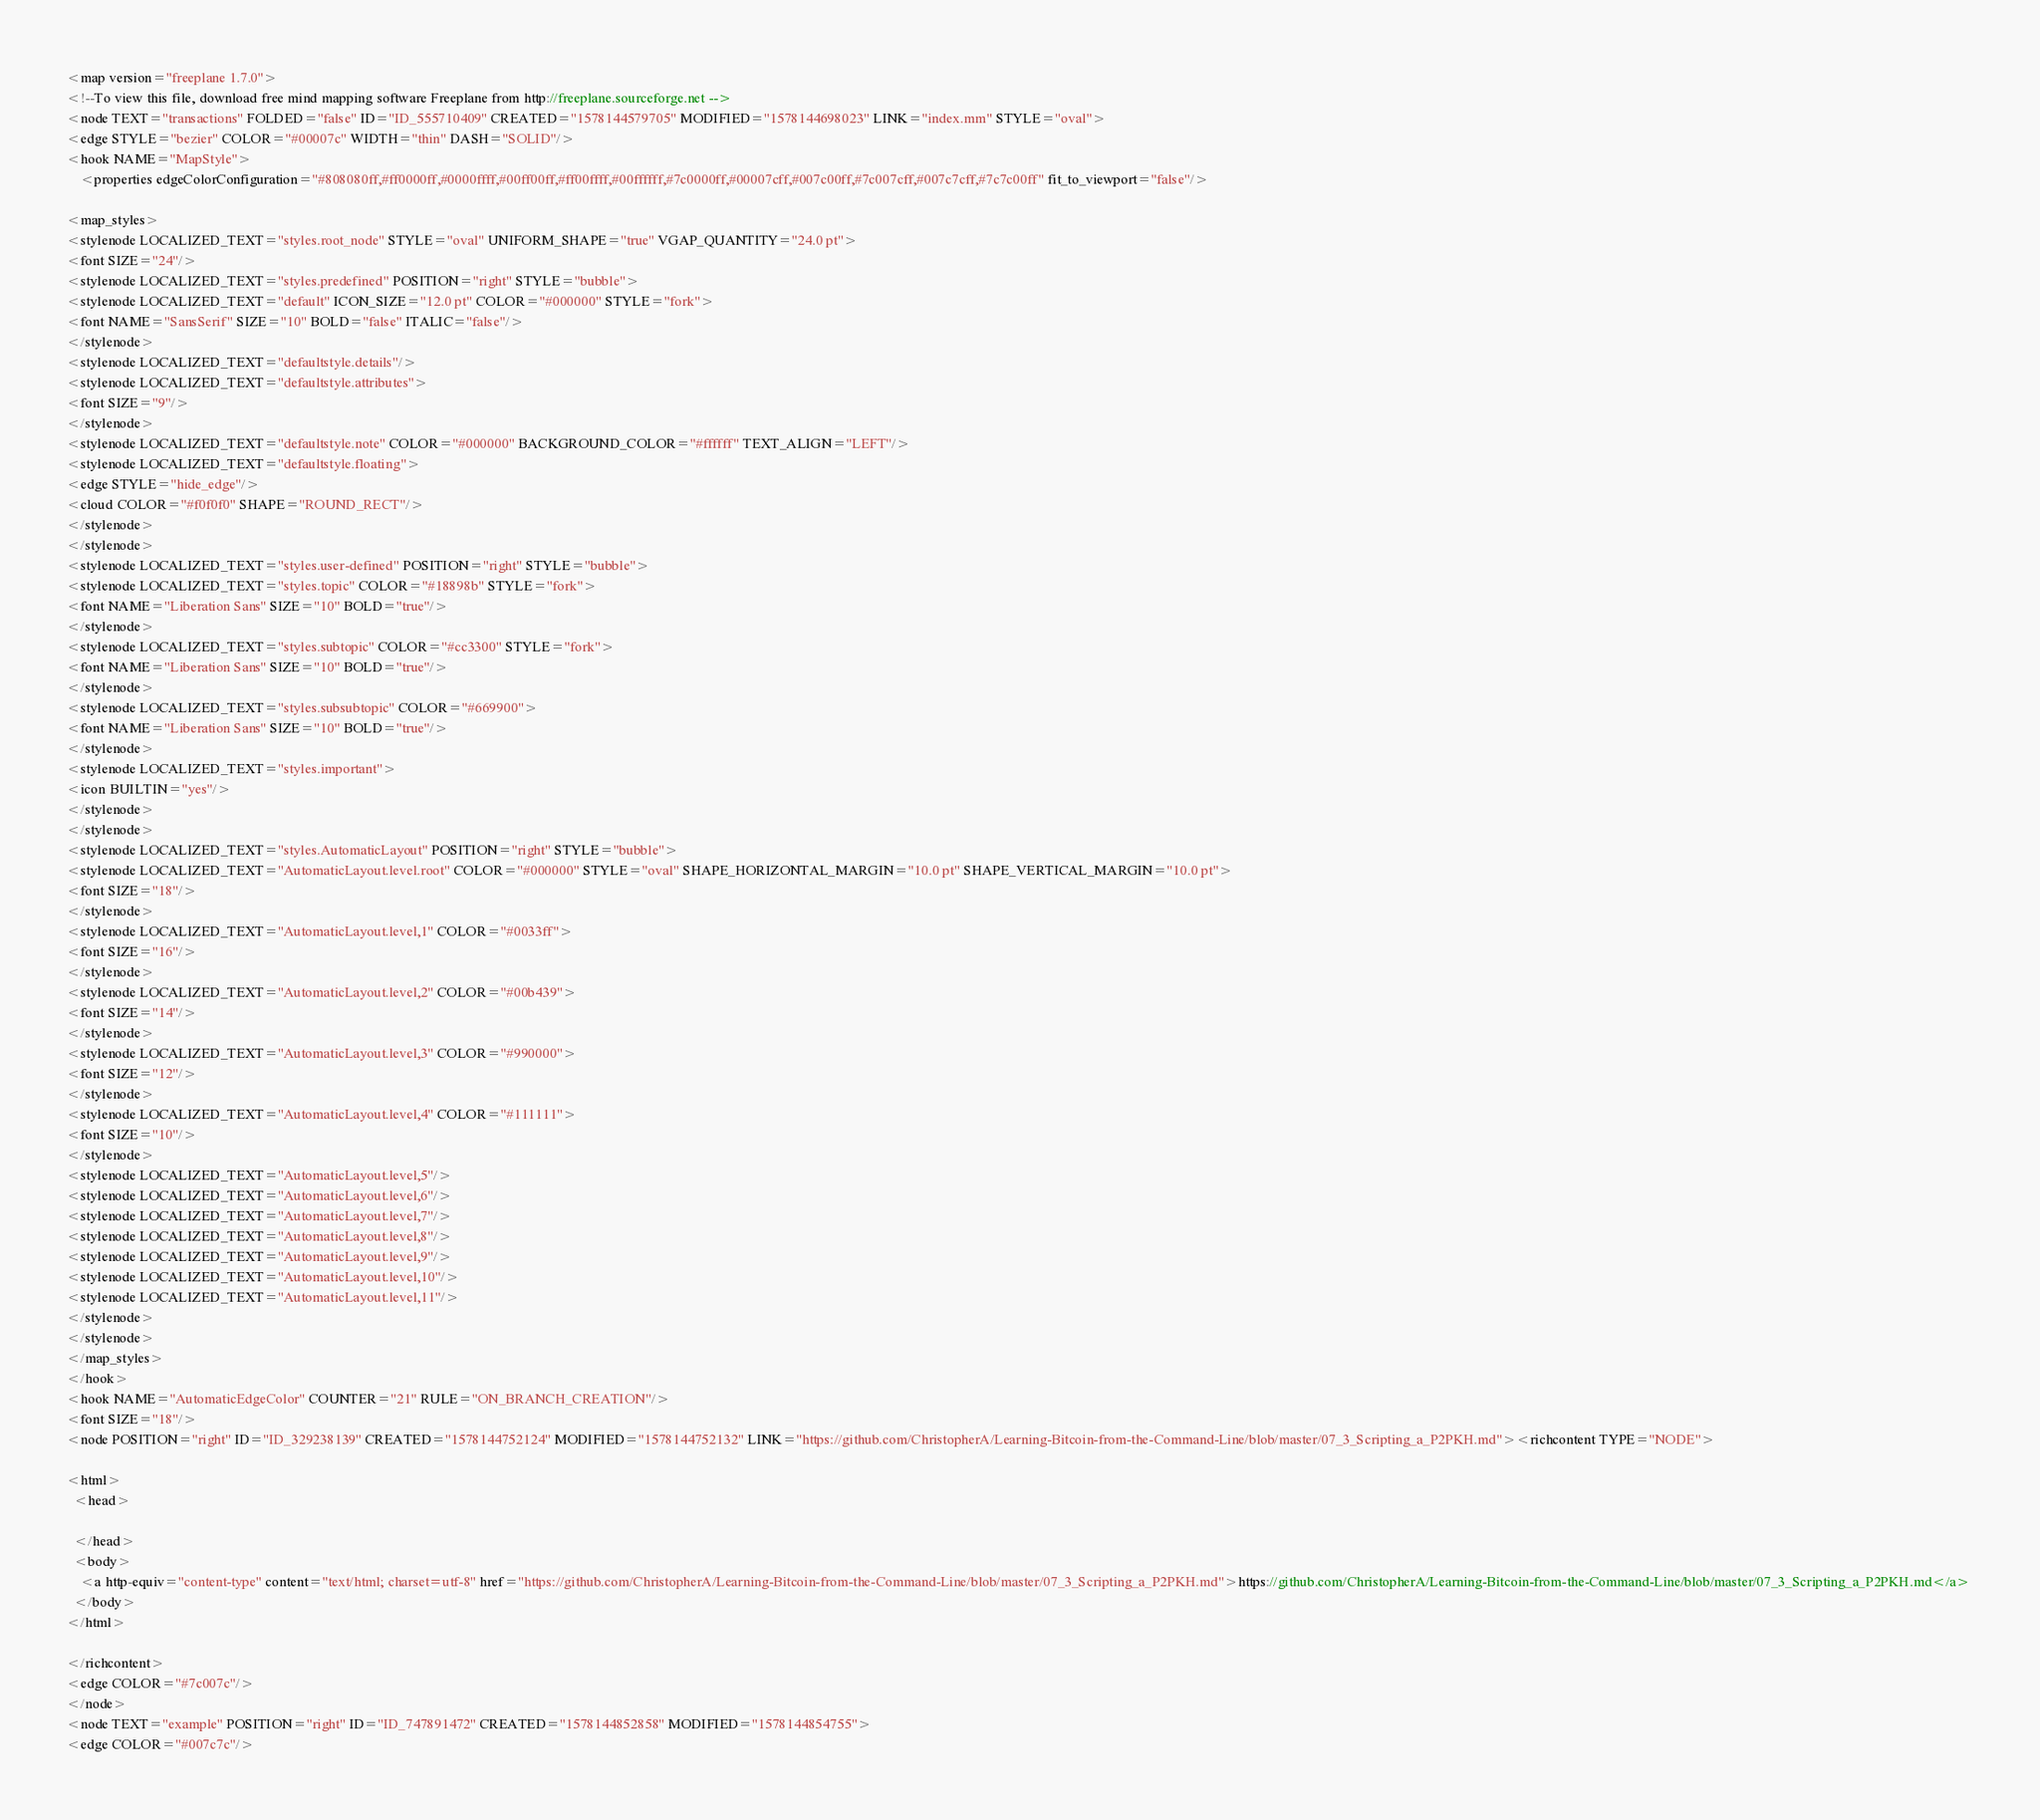Convert code to text. <code><loc_0><loc_0><loc_500><loc_500><_ObjectiveC_><map version="freeplane 1.7.0">
<!--To view this file, download free mind mapping software Freeplane from http://freeplane.sourceforge.net -->
<node TEXT="transactions" FOLDED="false" ID="ID_555710409" CREATED="1578144579705" MODIFIED="1578144698023" LINK="index.mm" STYLE="oval">
<edge STYLE="bezier" COLOR="#00007c" WIDTH="thin" DASH="SOLID"/>
<hook NAME="MapStyle">
    <properties edgeColorConfiguration="#808080ff,#ff0000ff,#0000ffff,#00ff00ff,#ff00ffff,#00ffffff,#7c0000ff,#00007cff,#007c00ff,#7c007cff,#007c7cff,#7c7c00ff" fit_to_viewport="false"/>

<map_styles>
<stylenode LOCALIZED_TEXT="styles.root_node" STYLE="oval" UNIFORM_SHAPE="true" VGAP_QUANTITY="24.0 pt">
<font SIZE="24"/>
<stylenode LOCALIZED_TEXT="styles.predefined" POSITION="right" STYLE="bubble">
<stylenode LOCALIZED_TEXT="default" ICON_SIZE="12.0 pt" COLOR="#000000" STYLE="fork">
<font NAME="SansSerif" SIZE="10" BOLD="false" ITALIC="false"/>
</stylenode>
<stylenode LOCALIZED_TEXT="defaultstyle.details"/>
<stylenode LOCALIZED_TEXT="defaultstyle.attributes">
<font SIZE="9"/>
</stylenode>
<stylenode LOCALIZED_TEXT="defaultstyle.note" COLOR="#000000" BACKGROUND_COLOR="#ffffff" TEXT_ALIGN="LEFT"/>
<stylenode LOCALIZED_TEXT="defaultstyle.floating">
<edge STYLE="hide_edge"/>
<cloud COLOR="#f0f0f0" SHAPE="ROUND_RECT"/>
</stylenode>
</stylenode>
<stylenode LOCALIZED_TEXT="styles.user-defined" POSITION="right" STYLE="bubble">
<stylenode LOCALIZED_TEXT="styles.topic" COLOR="#18898b" STYLE="fork">
<font NAME="Liberation Sans" SIZE="10" BOLD="true"/>
</stylenode>
<stylenode LOCALIZED_TEXT="styles.subtopic" COLOR="#cc3300" STYLE="fork">
<font NAME="Liberation Sans" SIZE="10" BOLD="true"/>
</stylenode>
<stylenode LOCALIZED_TEXT="styles.subsubtopic" COLOR="#669900">
<font NAME="Liberation Sans" SIZE="10" BOLD="true"/>
</stylenode>
<stylenode LOCALIZED_TEXT="styles.important">
<icon BUILTIN="yes"/>
</stylenode>
</stylenode>
<stylenode LOCALIZED_TEXT="styles.AutomaticLayout" POSITION="right" STYLE="bubble">
<stylenode LOCALIZED_TEXT="AutomaticLayout.level.root" COLOR="#000000" STYLE="oval" SHAPE_HORIZONTAL_MARGIN="10.0 pt" SHAPE_VERTICAL_MARGIN="10.0 pt">
<font SIZE="18"/>
</stylenode>
<stylenode LOCALIZED_TEXT="AutomaticLayout.level,1" COLOR="#0033ff">
<font SIZE="16"/>
</stylenode>
<stylenode LOCALIZED_TEXT="AutomaticLayout.level,2" COLOR="#00b439">
<font SIZE="14"/>
</stylenode>
<stylenode LOCALIZED_TEXT="AutomaticLayout.level,3" COLOR="#990000">
<font SIZE="12"/>
</stylenode>
<stylenode LOCALIZED_TEXT="AutomaticLayout.level,4" COLOR="#111111">
<font SIZE="10"/>
</stylenode>
<stylenode LOCALIZED_TEXT="AutomaticLayout.level,5"/>
<stylenode LOCALIZED_TEXT="AutomaticLayout.level,6"/>
<stylenode LOCALIZED_TEXT="AutomaticLayout.level,7"/>
<stylenode LOCALIZED_TEXT="AutomaticLayout.level,8"/>
<stylenode LOCALIZED_TEXT="AutomaticLayout.level,9"/>
<stylenode LOCALIZED_TEXT="AutomaticLayout.level,10"/>
<stylenode LOCALIZED_TEXT="AutomaticLayout.level,11"/>
</stylenode>
</stylenode>
</map_styles>
</hook>
<hook NAME="AutomaticEdgeColor" COUNTER="21" RULE="ON_BRANCH_CREATION"/>
<font SIZE="18"/>
<node POSITION="right" ID="ID_329238139" CREATED="1578144752124" MODIFIED="1578144752132" LINK="https://github.com/ChristopherA/Learning-Bitcoin-from-the-Command-Line/blob/master/07_3_Scripting_a_P2PKH.md"><richcontent TYPE="NODE">

<html>
  <head>
    
  </head>
  <body>
    <a http-equiv="content-type" content="text/html; charset=utf-8" href="https://github.com/ChristopherA/Learning-Bitcoin-from-the-Command-Line/blob/master/07_3_Scripting_a_P2PKH.md">https://github.com/ChristopherA/Learning-Bitcoin-from-the-Command-Line/blob/master/07_3_Scripting_a_P2PKH.md</a> 
  </body>
</html>

</richcontent>
<edge COLOR="#7c007c"/>
</node>
<node TEXT="example" POSITION="right" ID="ID_747891472" CREATED="1578144852858" MODIFIED="1578144854755">
<edge COLOR="#007c7c"/></code> 